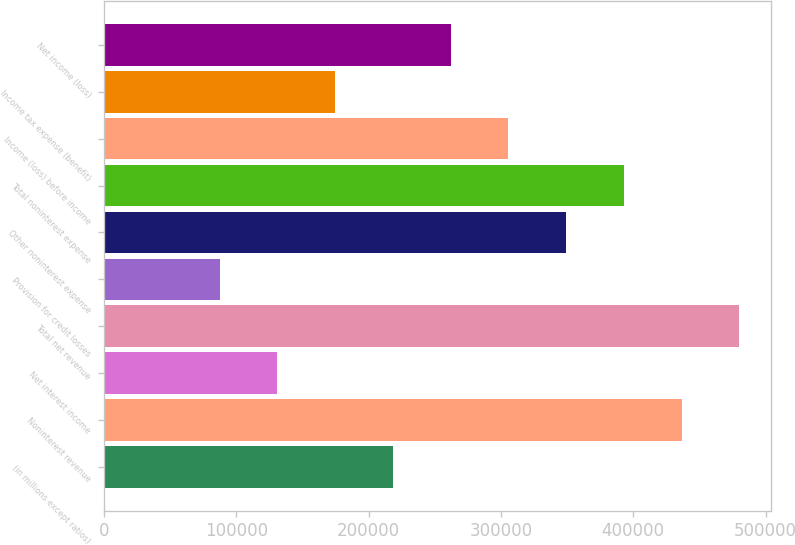Convert chart to OTSL. <chart><loc_0><loc_0><loc_500><loc_500><bar_chart><fcel>(in millions except ratios)<fcel>Noninterest revenue<fcel>Net interest income<fcel>Total net revenue<fcel>Provision for credit losses<fcel>Other noninterest expense<fcel>Total noninterest expense<fcel>Income (loss) before income<fcel>Income tax expense (benefit)<fcel>Net income (loss)<nl><fcel>218252<fcel>436488<fcel>130957<fcel>480135<fcel>87309.6<fcel>349193<fcel>392841<fcel>305546<fcel>174604<fcel>261899<nl></chart> 